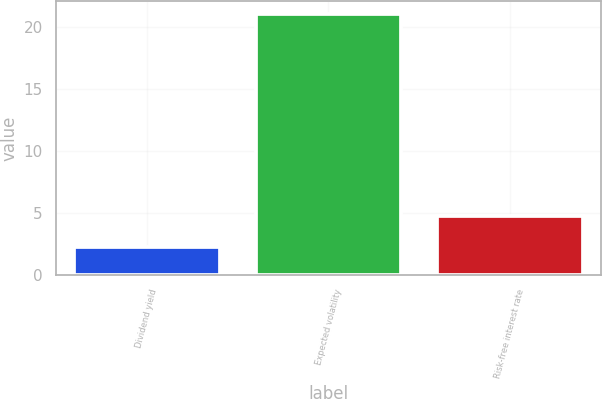Convert chart. <chart><loc_0><loc_0><loc_500><loc_500><bar_chart><fcel>Dividend yield<fcel>Expected volatility<fcel>Risk-free interest rate<nl><fcel>2.2<fcel>21<fcel>4.7<nl></chart> 